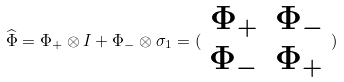Convert formula to latex. <formula><loc_0><loc_0><loc_500><loc_500>\widehat { \Phi } = \Phi _ { + } \otimes I + \Phi _ { - } \otimes \sigma _ { 1 } = ( \begin{array} { c c } \Phi _ { + } & \Phi _ { - } \\ \Phi _ { - } & \Phi _ { + } \end{array} )</formula> 